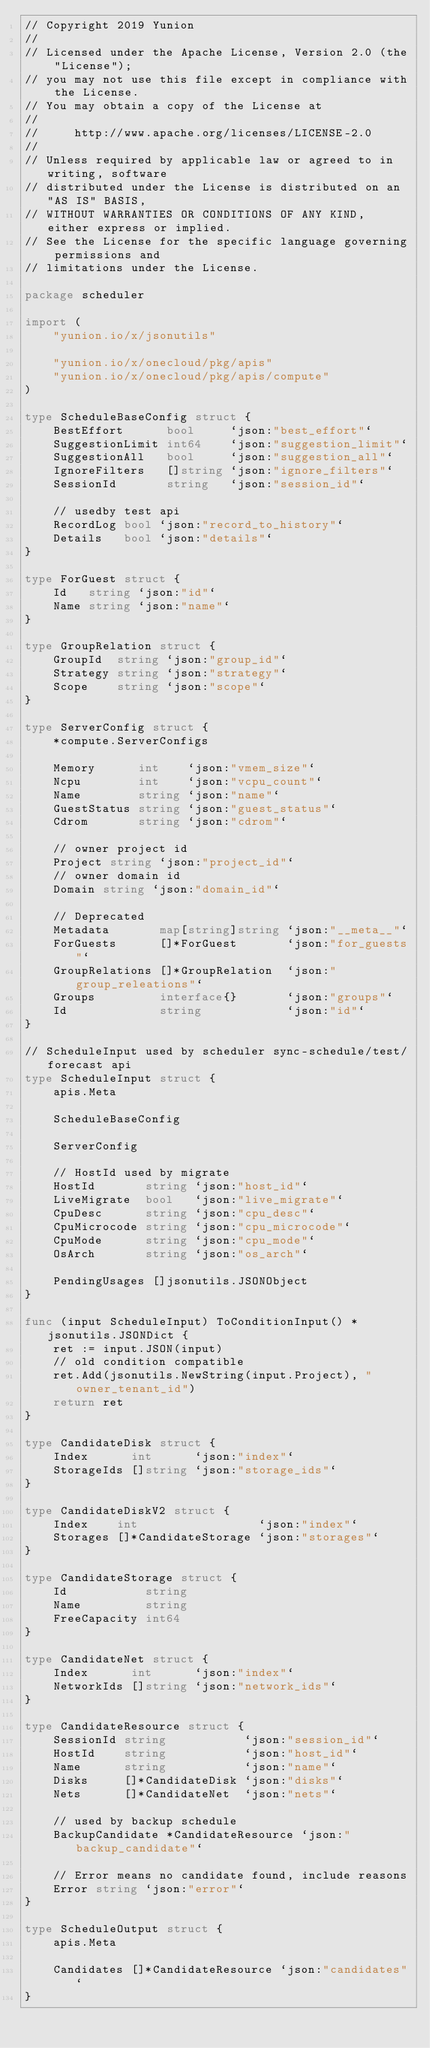Convert code to text. <code><loc_0><loc_0><loc_500><loc_500><_Go_>// Copyright 2019 Yunion
//
// Licensed under the Apache License, Version 2.0 (the "License");
// you may not use this file except in compliance with the License.
// You may obtain a copy of the License at
//
//     http://www.apache.org/licenses/LICENSE-2.0
//
// Unless required by applicable law or agreed to in writing, software
// distributed under the License is distributed on an "AS IS" BASIS,
// WITHOUT WARRANTIES OR CONDITIONS OF ANY KIND, either express or implied.
// See the License for the specific language governing permissions and
// limitations under the License.

package scheduler

import (
	"yunion.io/x/jsonutils"

	"yunion.io/x/onecloud/pkg/apis"
	"yunion.io/x/onecloud/pkg/apis/compute"
)

type ScheduleBaseConfig struct {
	BestEffort      bool     `json:"best_effort"`
	SuggestionLimit int64    `json:"suggestion_limit"`
	SuggestionAll   bool     `json:"suggestion_all"`
	IgnoreFilters   []string `json:"ignore_filters"`
	SessionId       string   `json:"session_id"`

	// usedby test api
	RecordLog bool `json:"record_to_history"`
	Details   bool `json:"details"`
}

type ForGuest struct {
	Id   string `json:"id"`
	Name string `json:"name"`
}

type GroupRelation struct {
	GroupId  string `json:"group_id"`
	Strategy string `json:"strategy"`
	Scope    string `json:"scope"`
}

type ServerConfig struct {
	*compute.ServerConfigs

	Memory      int    `json:"vmem_size"`
	Ncpu        int    `json:"vcpu_count"`
	Name        string `json:"name"`
	GuestStatus string `json:"guest_status"`
	Cdrom       string `json:"cdrom"`

	// owner project id
	Project string `json:"project_id"`
	// owner domain id
	Domain string `json:"domain_id"`

	// Deprecated
	Metadata       map[string]string `json:"__meta__"`
	ForGuests      []*ForGuest       `json:"for_guests"`
	GroupRelations []*GroupRelation  `json:"group_releations"`
	Groups         interface{}       `json:"groups"`
	Id             string            `json:"id"`
}

// ScheduleInput used by scheduler sync-schedule/test/forecast api
type ScheduleInput struct {
	apis.Meta

	ScheduleBaseConfig

	ServerConfig

	// HostId used by migrate
	HostId       string `json:"host_id"`
	LiveMigrate  bool   `json:"live_migrate"`
	CpuDesc      string `json:"cpu_desc"`
	CpuMicrocode string `json:"cpu_microcode"`
	CpuMode      string `json:"cpu_mode"`
	OsArch       string `json:"os_arch"`

	PendingUsages []jsonutils.JSONObject
}

func (input ScheduleInput) ToConditionInput() *jsonutils.JSONDict {
	ret := input.JSON(input)
	// old condition compatible
	ret.Add(jsonutils.NewString(input.Project), "owner_tenant_id")
	return ret
}

type CandidateDisk struct {
	Index      int      `json:"index"`
	StorageIds []string `json:"storage_ids"`
}

type CandidateDiskV2 struct {
	Index    int                 `json:"index"`
	Storages []*CandidateStorage `json:"storages"`
}

type CandidateStorage struct {
	Id           string
	Name         string
	FreeCapacity int64
}

type CandidateNet struct {
	Index      int      `json:"index"`
	NetworkIds []string `json:"network_ids"`
}

type CandidateResource struct {
	SessionId string           `json:"session_id"`
	HostId    string           `json:"host_id"`
	Name      string           `json:"name"`
	Disks     []*CandidateDisk `json:"disks"`
	Nets      []*CandidateNet  `json:"nets"`

	// used by backup schedule
	BackupCandidate *CandidateResource `json:"backup_candidate"`

	// Error means no candidate found, include reasons
	Error string `json:"error"`
}

type ScheduleOutput struct {
	apis.Meta

	Candidates []*CandidateResource `json:"candidates"`
}
</code> 